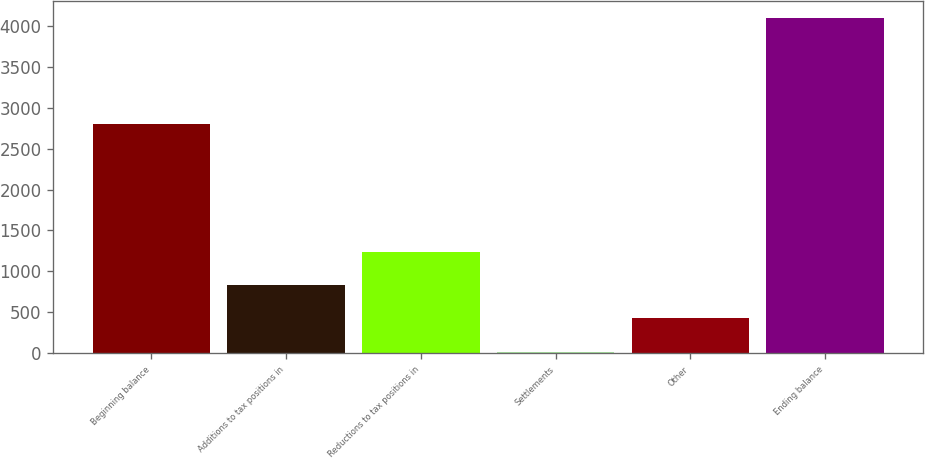Convert chart to OTSL. <chart><loc_0><loc_0><loc_500><loc_500><bar_chart><fcel>Beginning balance<fcel>Additions to tax positions in<fcel>Reductions to tax positions in<fcel>Settlements<fcel>Other<fcel>Ending balance<nl><fcel>2803<fcel>832<fcel>1240<fcel>16<fcel>424<fcel>4096<nl></chart> 